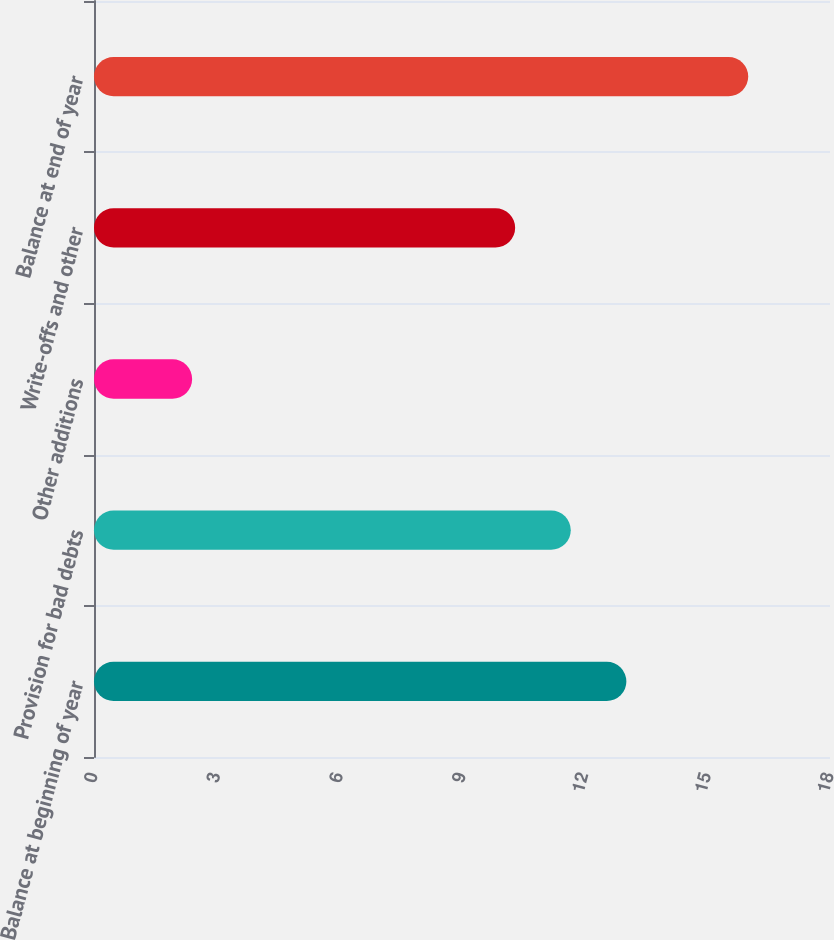Convert chart to OTSL. <chart><loc_0><loc_0><loc_500><loc_500><bar_chart><fcel>Balance at beginning of year<fcel>Provision for bad debts<fcel>Other additions<fcel>Write-offs and other<fcel>Balance at end of year<nl><fcel>13.02<fcel>11.66<fcel>2.4<fcel>10.3<fcel>16<nl></chart> 